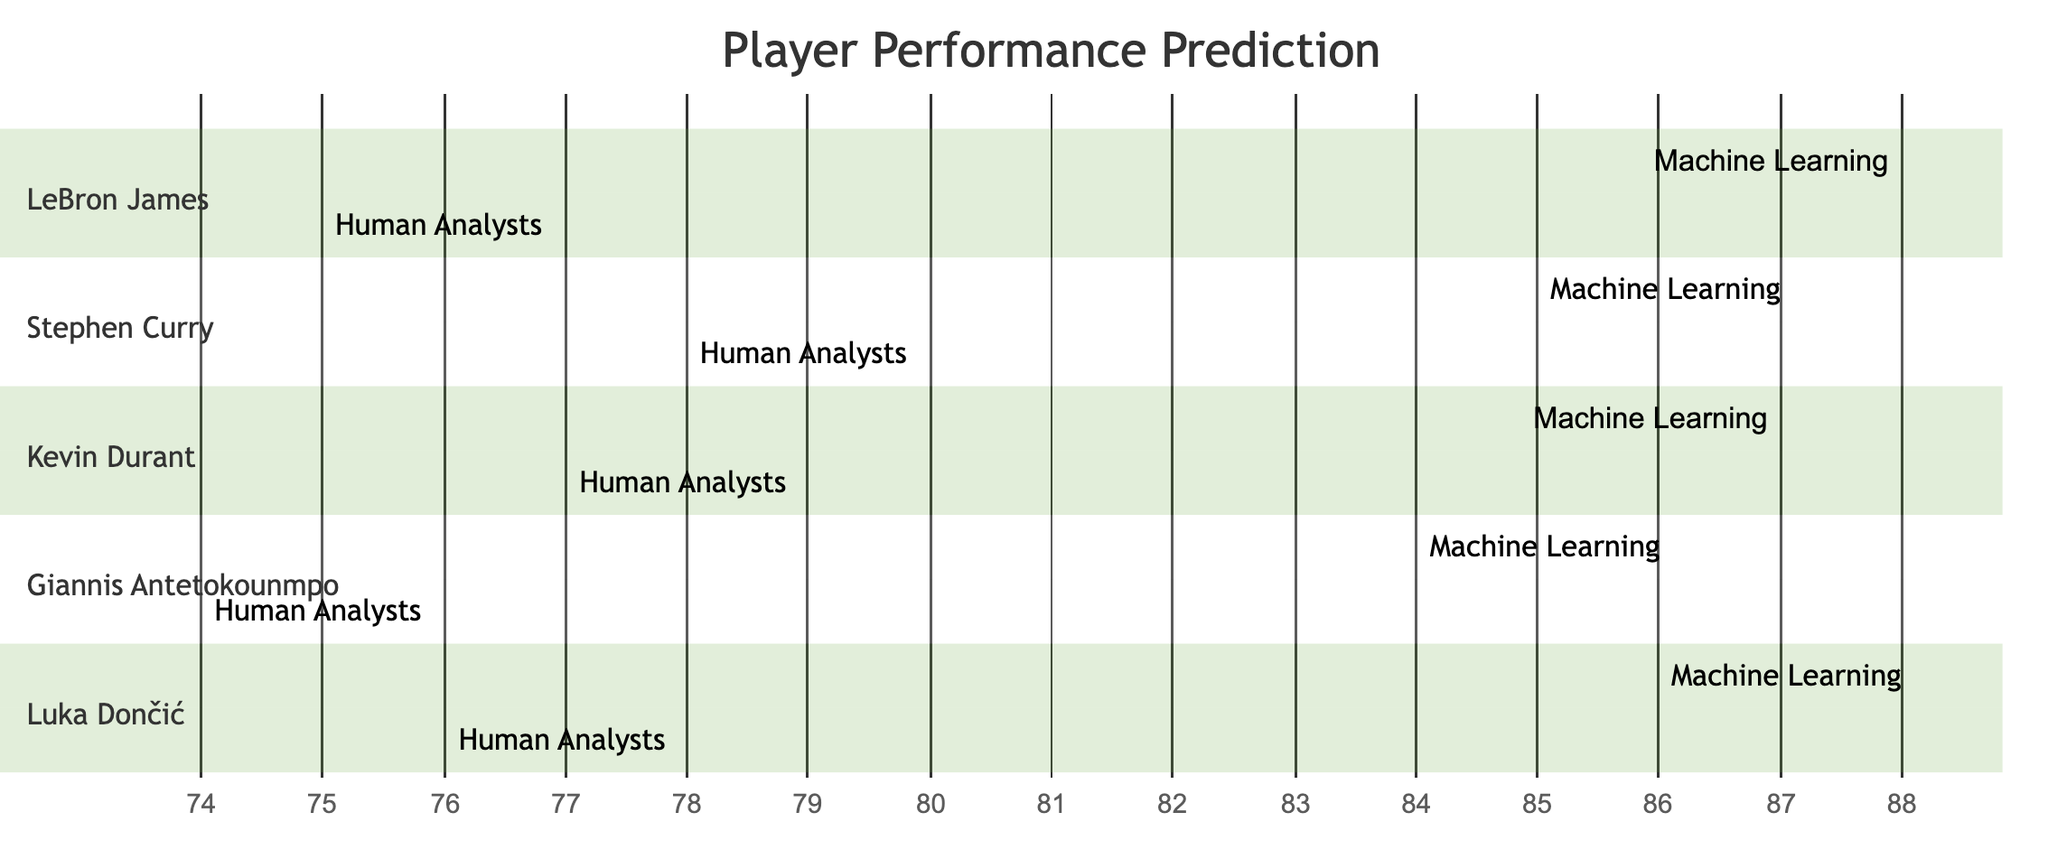What is the predictive score of LeBron James using Machine Learning? The diagram indicates that the predictive score for LeBron James using Machine Learning is 88.
Answer: 88 What is the predictive score of Kevin Durant from Human Analysts? According to the diagram, the predictive score for Kevin Durant from Human Analysts is 77.
Answer: 77 How many players are included in the diagram? By counting each player represented in the sections of the diagram, we find there are five players: LeBron James, Stephen Curry, Kevin Durant, Giannis Antetokounmpo, and Luka Dončić.
Answer: 5 Which player has the highest Machine Learning predictive score? The diagram shows that LeBron James has the highest Machine Learning predictive score at 88, which is greater than the scores of the other players.
Answer: LeBron James What is the difference between the Machine Learning and Human Analysts scores for Luka Dončić? For Luka Dončić, the Machine Learning score is 86 and the Human Analysts score is 76. The difference can be calculated as 86 - 76, which equals 10.
Answer: 10 Which player shows the lowest predictive score from Human Analysts? Giannis Antetokounmpo has the lowest Human Analysts score of 74, which is lower than the scores of the other players.
Answer: Giannis Antetokounmpo What can be inferred about the general trend in predictive performance between Machine Learning and Human Analysts? The diagram illustrates that Machine Learning consistently outperforms Human Analysts across all players' predictive scores, indicating a general trend of higher scores with Machine Learning.
Answer: Machine Learning consistently outperforms Human Analysts What is the predictive score of Stephen Curry from Machine Learning? According to the diagram, Stephen Curry's Machine Learning predictive score is 85.
Answer: 85 Which player has a closer score between Machine Learning and Human Analysts? Luka Dončić has scores of 86 from Machine Learning and 76 from Human Analysts, resulting in a smaller difference compared to other players, indicating closer scores.
Answer: Luka Dončić 